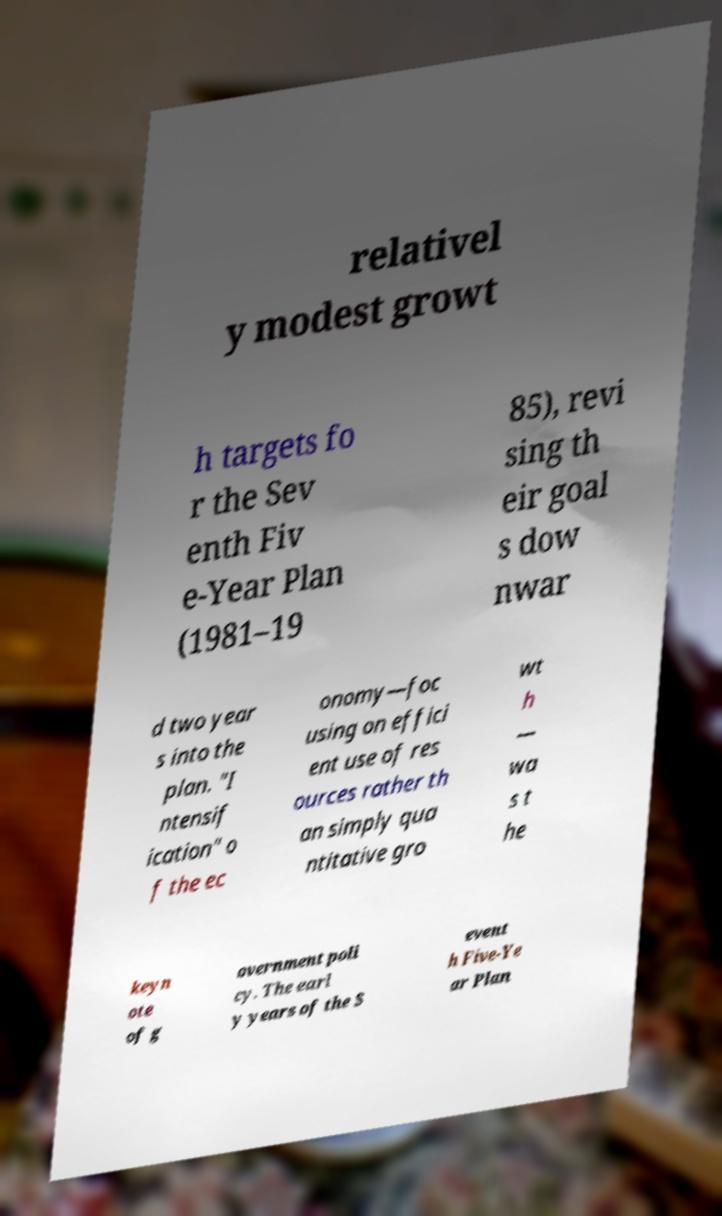Can you read and provide the text displayed in the image?This photo seems to have some interesting text. Can you extract and type it out for me? relativel y modest growt h targets fo r the Sev enth Fiv e-Year Plan (1981–19 85), revi sing th eir goal s dow nwar d two year s into the plan. "I ntensif ication" o f the ec onomy—foc using on effici ent use of res ources rather th an simply qua ntitative gro wt h — wa s t he keyn ote of g overnment poli cy. The earl y years of the S event h Five-Ye ar Plan 